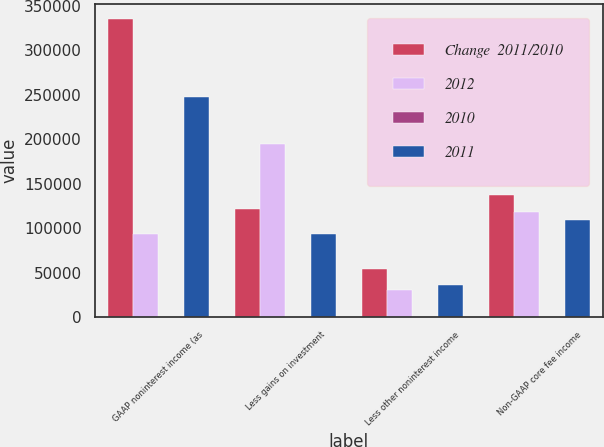<chart> <loc_0><loc_0><loc_500><loc_500><stacked_bar_chart><ecel><fcel>GAAP noninterest income (as<fcel>Less gains on investment<fcel>Less other noninterest income<fcel>Non-GAAP core fee income<nl><fcel>Change  2011/2010<fcel>335546<fcel>122114<fcel>54401<fcel>136911<nl><fcel>2012<fcel>93360<fcel>195034<fcel>30155<fcel>118462<nl><fcel>2010<fcel>12.2<fcel>37.4<fcel>80.4<fcel>15.6<nl><fcel>2011<fcel>247530<fcel>93360<fcel>35642<fcel>109006<nl></chart> 